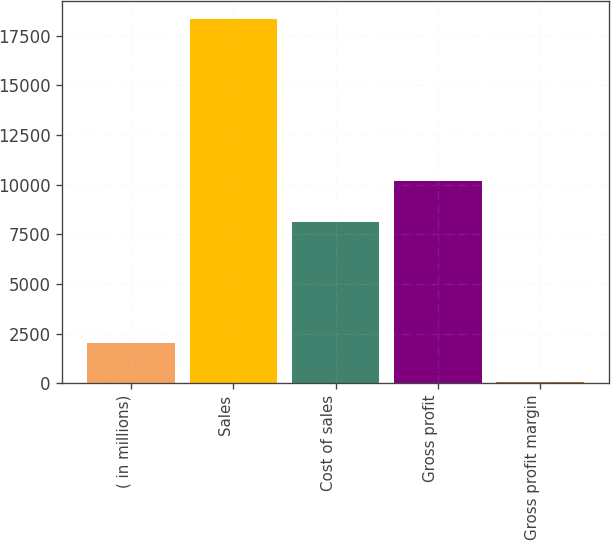Convert chart to OTSL. <chart><loc_0><loc_0><loc_500><loc_500><bar_chart><fcel>( in millions)<fcel>Sales<fcel>Cost of sales<fcel>Gross profit<fcel>Gross profit margin<nl><fcel>2017<fcel>18329.7<fcel>8137.2<fcel>10192.5<fcel>55.6<nl></chart> 